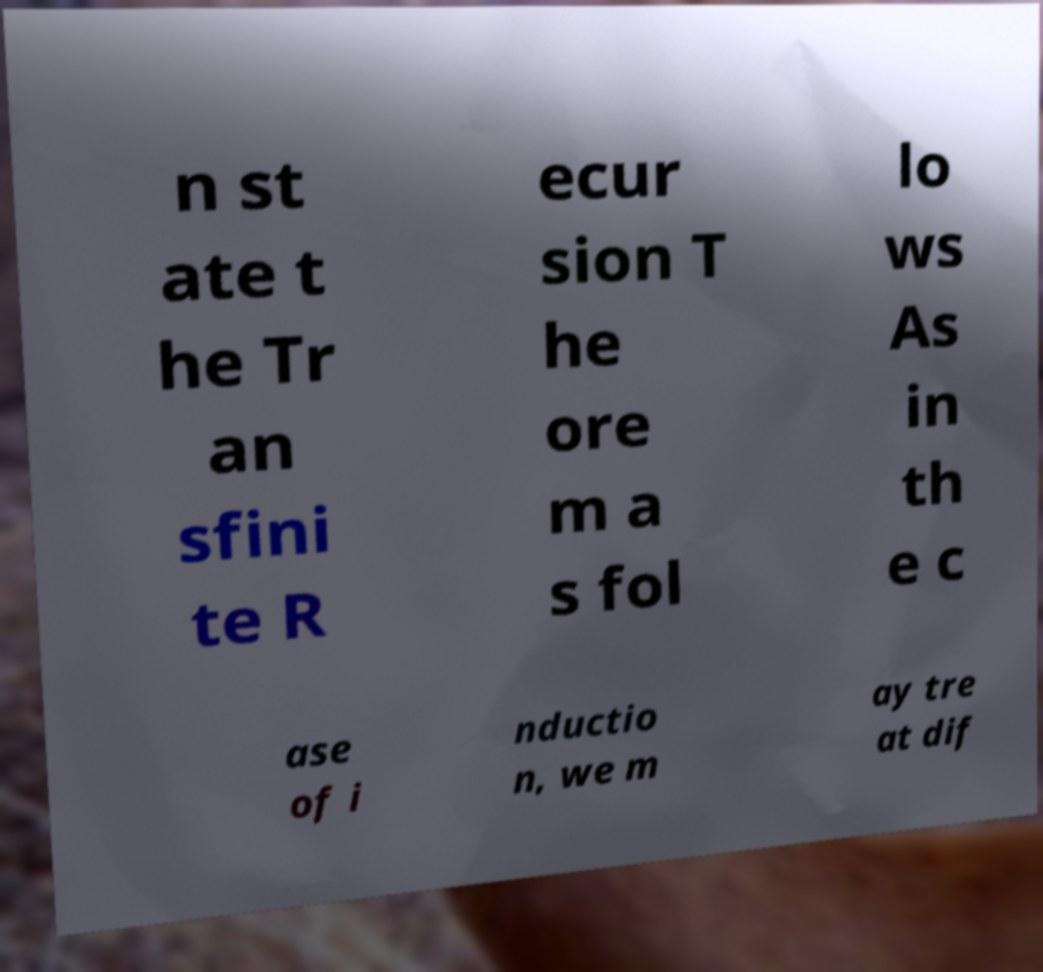For documentation purposes, I need the text within this image transcribed. Could you provide that? n st ate t he Tr an sfini te R ecur sion T he ore m a s fol lo ws As in th e c ase of i nductio n, we m ay tre at dif 